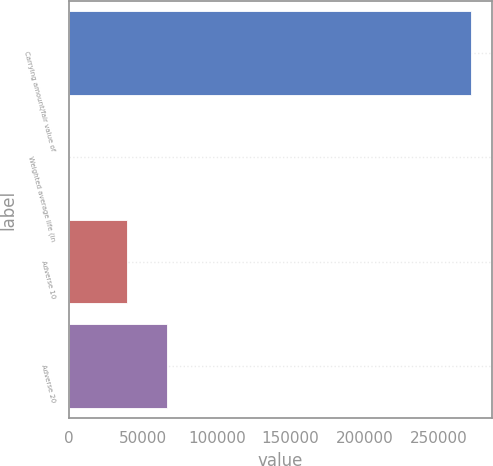Convert chart to OTSL. <chart><loc_0><loc_0><loc_500><loc_500><bar_chart><fcel>Carrying amount/fair value of<fcel>Weighted average life (in<fcel>Adverse 10<fcel>Adverse 20<nl><fcel>272472<fcel>1.3<fcel>39163<fcel>66410.1<nl></chart> 